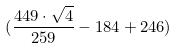Convert formula to latex. <formula><loc_0><loc_0><loc_500><loc_500>( \frac { 4 4 9 \cdot \sqrt { 4 } } { 2 5 9 } - 1 8 4 + 2 4 6 )</formula> 